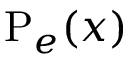<formula> <loc_0><loc_0><loc_500><loc_500>\mathrm P _ { e } ( x )</formula> 